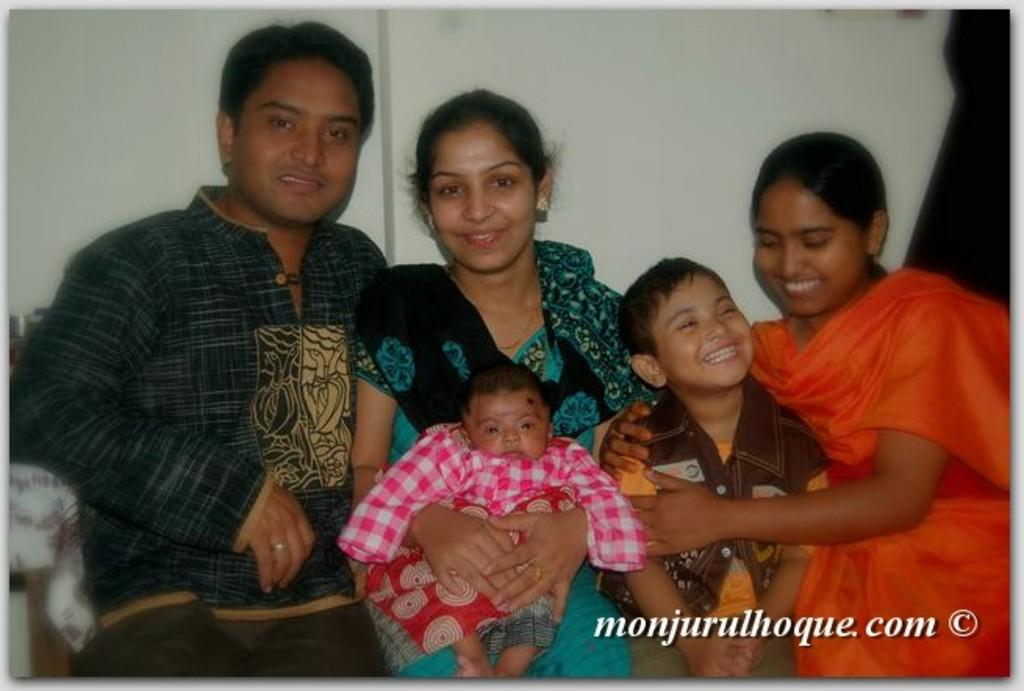What is the main subject of the image? The main subject of the image is a group of people. How are the people in the image depicted? The people are smiling in the image. Is there any text present in the image? Yes, there is text in the bottom right-hand side of the image. What can be seen in the background of the image? There is a wall in the background of the image. What type of fowl can be seen perched on the wall in the image? There is no fowl present on the wall in the image. Is there a church visible in the background of the image? No, there is no church visible in the image; only a wall is present in the background. 